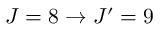Convert formula to latex. <formula><loc_0><loc_0><loc_500><loc_500>J = 8 \rightarrow J ^ { \prime } = 9</formula> 